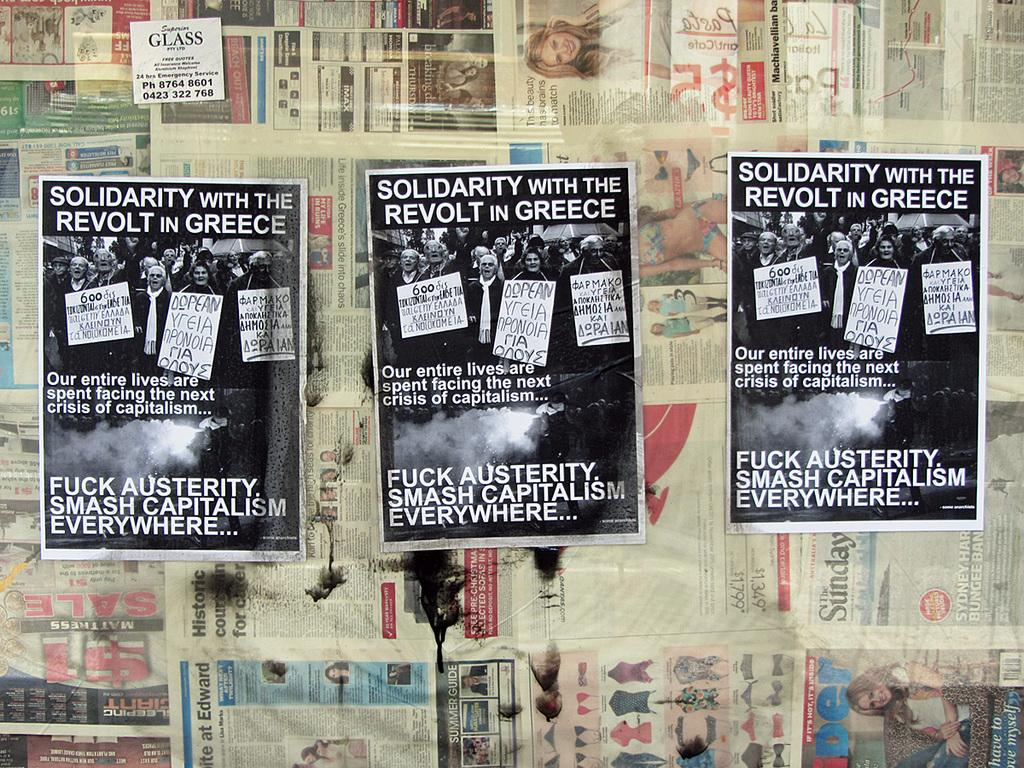<image>
Offer a succinct explanation of the picture presented. Posters that are on a wall for solidarity with the revolt in Greece. 